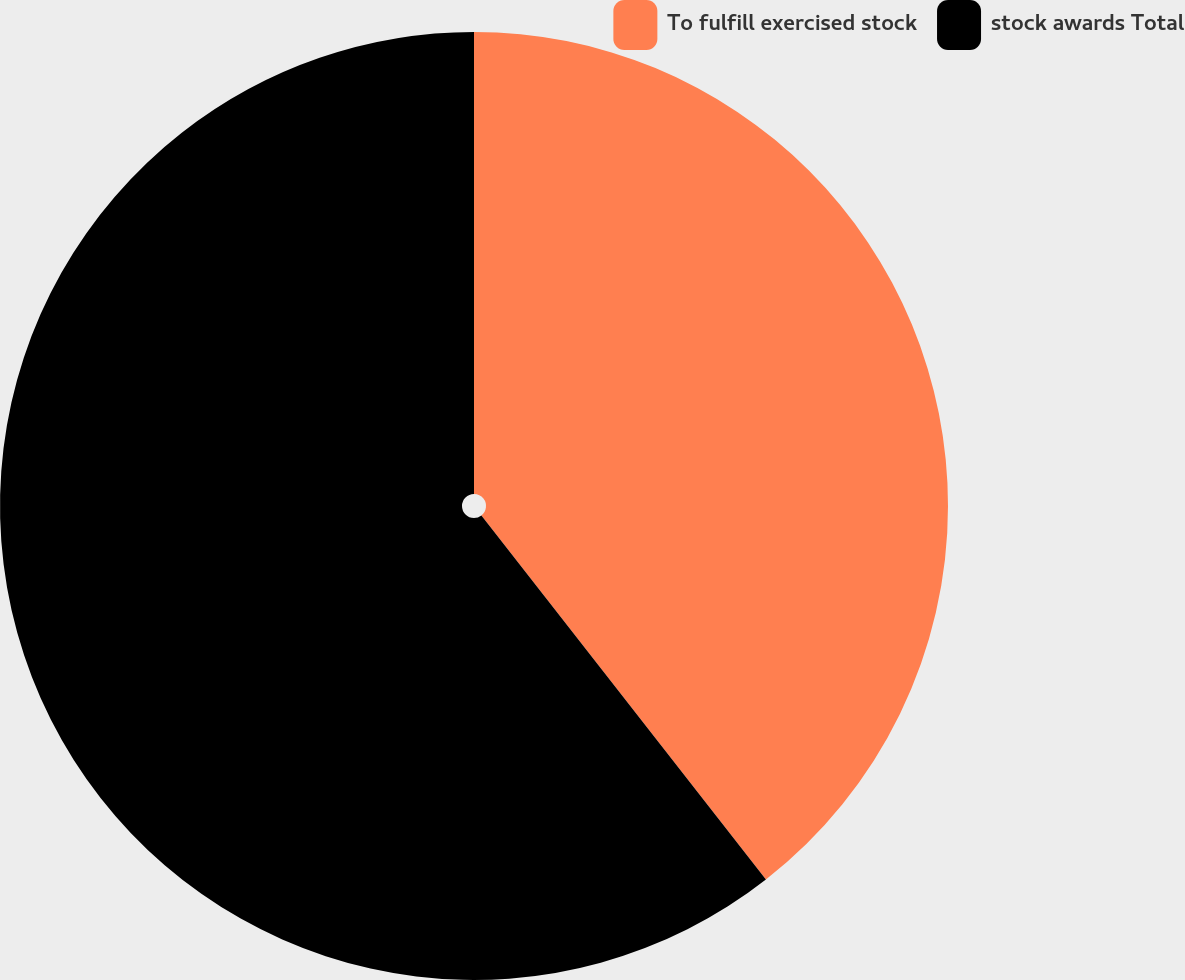Convert chart to OTSL. <chart><loc_0><loc_0><loc_500><loc_500><pie_chart><fcel>To fulfill exercised stock<fcel>stock awards Total<nl><fcel>39.44%<fcel>60.56%<nl></chart> 